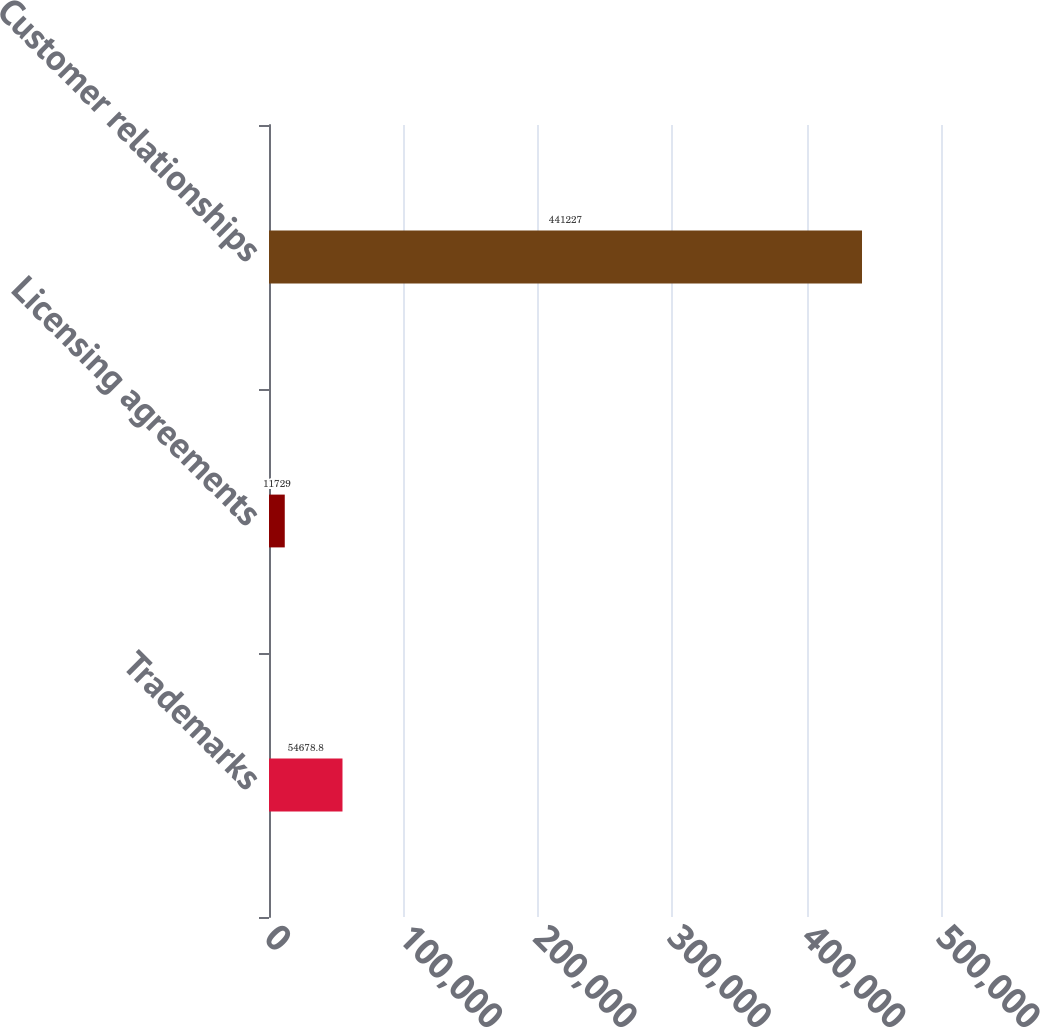Convert chart. <chart><loc_0><loc_0><loc_500><loc_500><bar_chart><fcel>Trademarks<fcel>Licensing agreements<fcel>Customer relationships<nl><fcel>54678.8<fcel>11729<fcel>441227<nl></chart> 